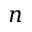<formula> <loc_0><loc_0><loc_500><loc_500>n</formula> 